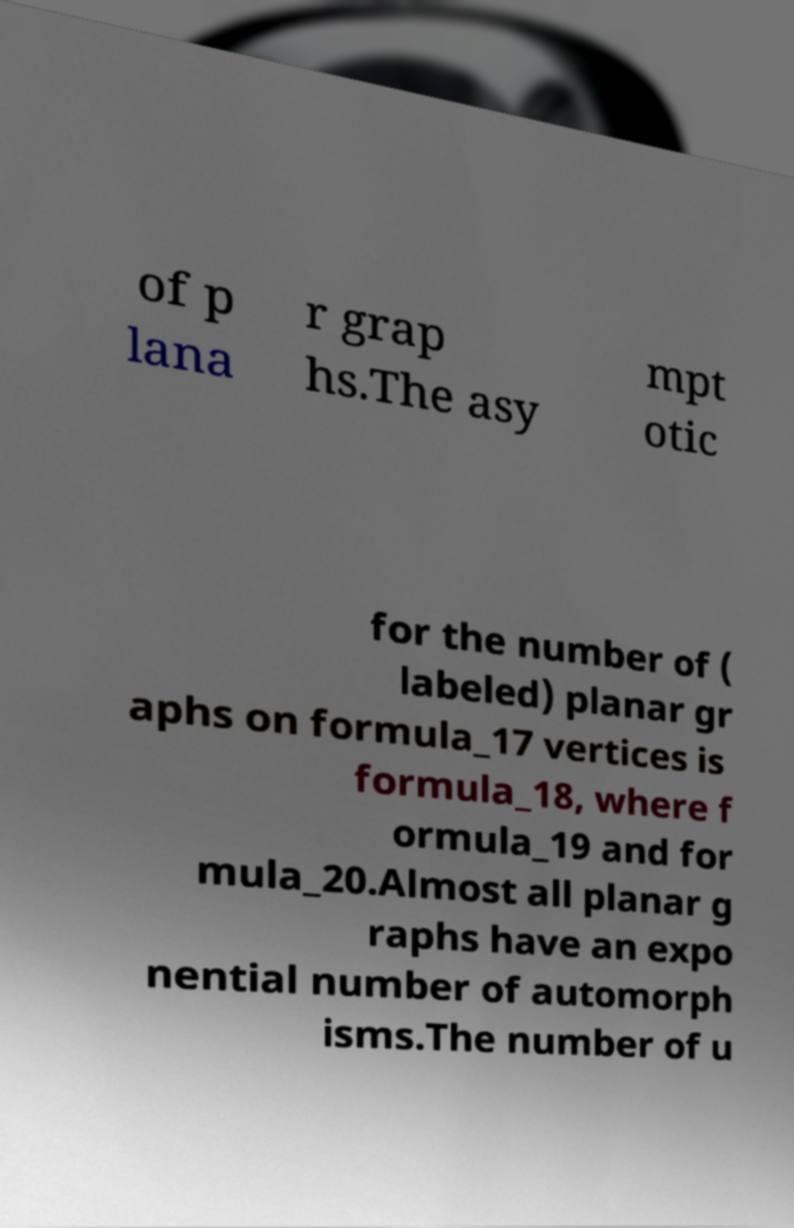Please identify and transcribe the text found in this image. of p lana r grap hs.The asy mpt otic for the number of ( labeled) planar gr aphs on formula_17 vertices is formula_18, where f ormula_19 and for mula_20.Almost all planar g raphs have an expo nential number of automorph isms.The number of u 